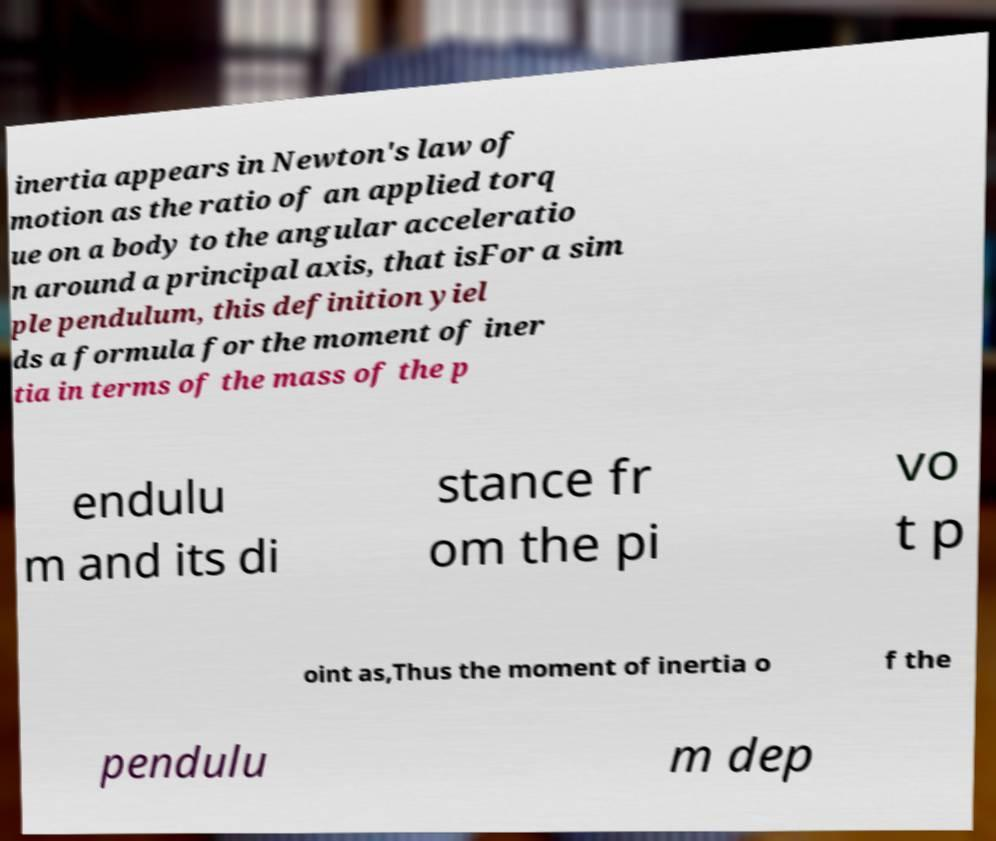Can you read and provide the text displayed in the image?This photo seems to have some interesting text. Can you extract and type it out for me? inertia appears in Newton's law of motion as the ratio of an applied torq ue on a body to the angular acceleratio n around a principal axis, that isFor a sim ple pendulum, this definition yiel ds a formula for the moment of iner tia in terms of the mass of the p endulu m and its di stance fr om the pi vo t p oint as,Thus the moment of inertia o f the pendulu m dep 